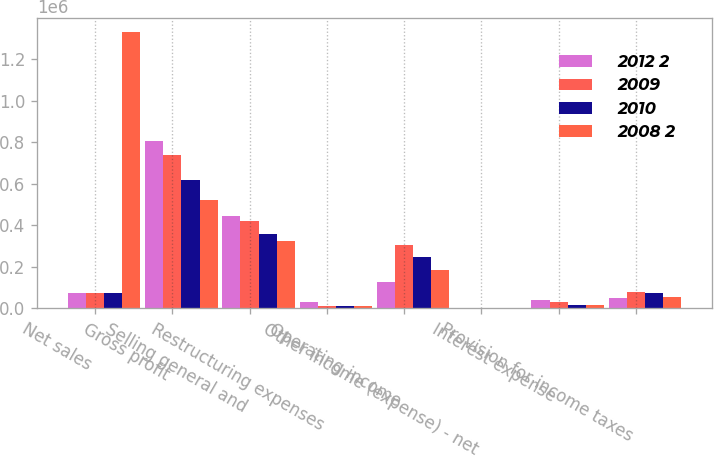Convert chart. <chart><loc_0><loc_0><loc_500><loc_500><stacked_bar_chart><ecel><fcel>Net sales<fcel>Gross profit<fcel>Selling general and<fcel>Restructuring expenses<fcel>Operating income<fcel>Other income (expense) - net<fcel>Interest expense<fcel>Provision for income taxes<nl><fcel>2012 2<fcel>74774<fcel>803700<fcel>444490<fcel>32473<fcel>128218<fcel>236<fcel>42250<fcel>48574<nl><fcel>2009<fcel>74774<fcel>738673<fcel>421703<fcel>12314<fcel>304656<fcel>1443<fcel>29332<fcel>80024<nl><fcel>2010<fcel>74774<fcel>618483<fcel>358272<fcel>11095<fcel>249116<fcel>1092<fcel>16150<fcel>74774<nl><fcel>2008 2<fcel>1.32966e+06<fcel>522386<fcel>325453<fcel>12079<fcel>184854<fcel>1151<fcel>17178<fcel>55436<nl></chart> 